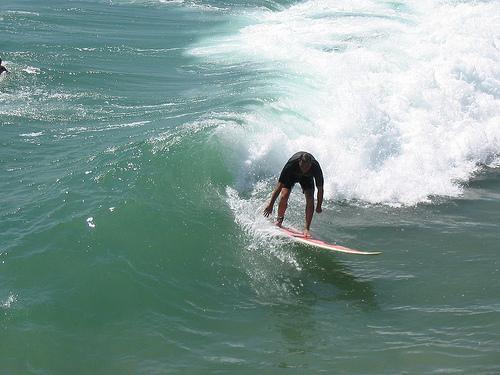How many people are shown?
Give a very brief answer. 1. 